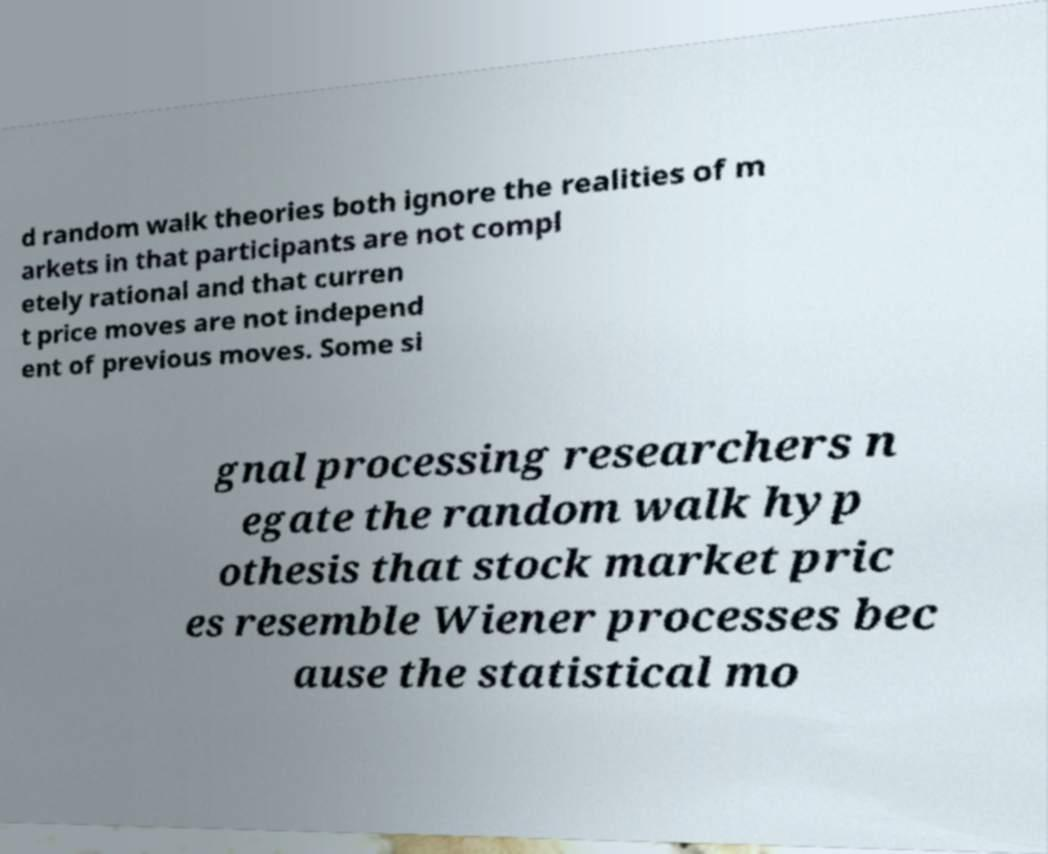For documentation purposes, I need the text within this image transcribed. Could you provide that? d random walk theories both ignore the realities of m arkets in that participants are not compl etely rational and that curren t price moves are not independ ent of previous moves. Some si gnal processing researchers n egate the random walk hyp othesis that stock market pric es resemble Wiener processes bec ause the statistical mo 